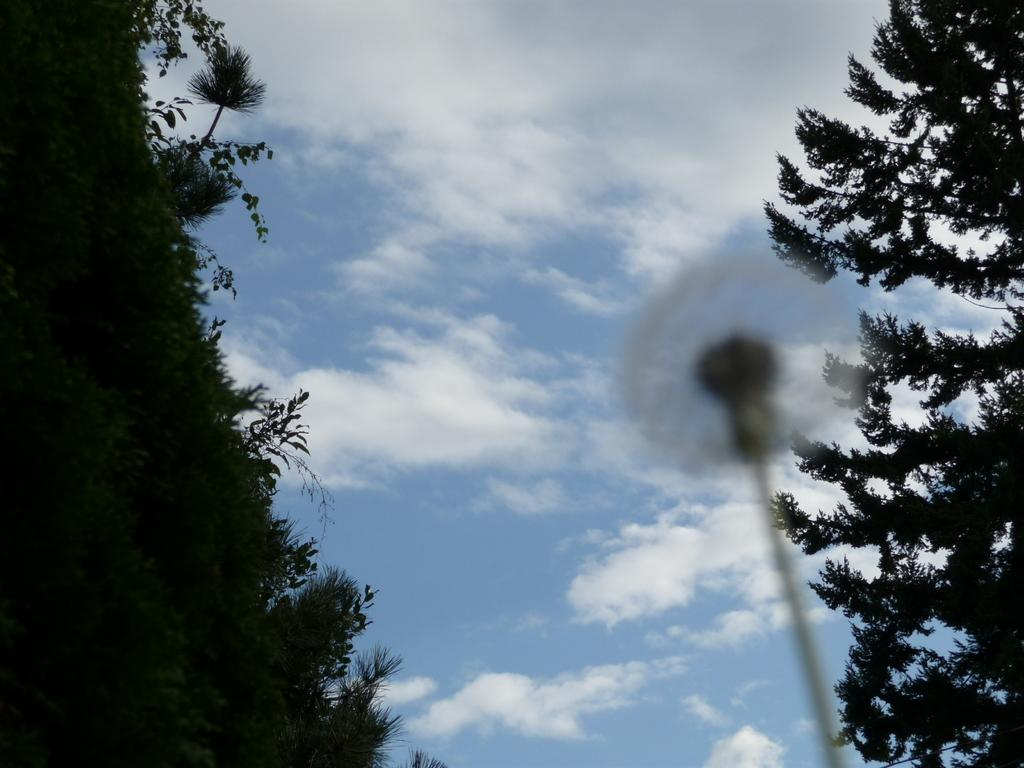What type of vegetation can be seen on both sides of the image? There are trees on the right side and the left side of the image. What is visible in the background of the image? The sky is visible in the image. What is located in the center of the image? There is a pole in the center of the image. What type of crack can be seen in the image? There is no crack present in the image. Can you see a snake in the image? There is no snake present in the image. 